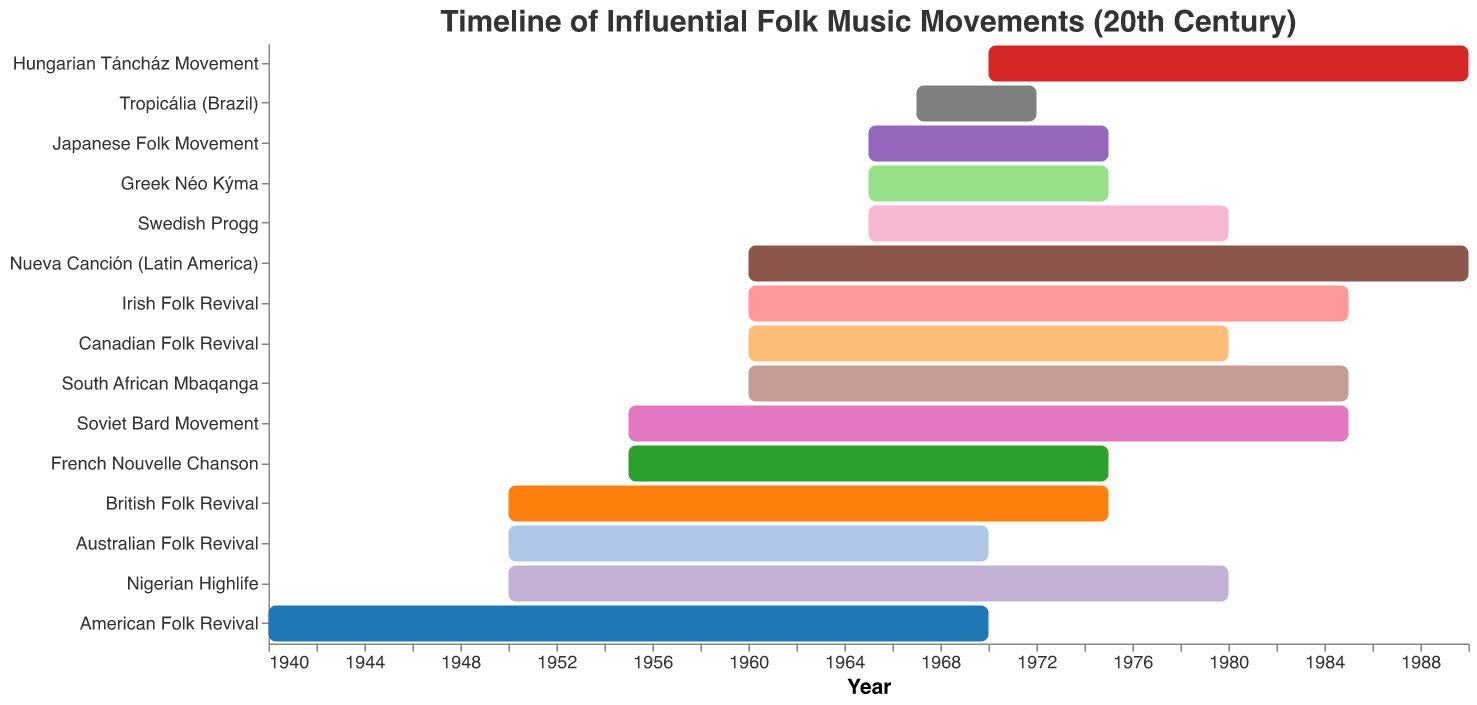What is the title of the chart? The title of the chart is usually located at the top and clearly states what the chart is about. By reading the title, we see that it's called "Timeline of Influential Folk Music Movements (20th Century)".
Answer: Timeline of Influential Folk Music Movements (20th Century) Which folk music movement has the longest duration? To find the movement with the longest duration, calculate the difference between the end and start years for each movement and compare them. Nueva Canción (Latin America) spans from 1960 to 1990, lasting 30 years.
Answer: Nueva Canción (Latin America) Which two movements both started in 1950? By examining the chart, we can see that the British Folk Revival and Australian Folk Revival both began in 1950.
Answer: British Folk Revival, Australian Folk Revival How many folk movements started in the 1960s? Count the number of bars that have their start year in the 1960s. Nueva Canción (Latin America), Irish Folk Revival, South African Mbaqanga, and Japanese Folk Movement started during this period, making a total of 4.
Answer: 4 Which movement ended last? By identifying the movement with the latest end year, we see that Nueva Canción (Latin America) ended in 1990, which is the latest among all the listed movements.
Answer: Nueva Canción (Latin America) What is the median start year of all the folk movements listed? List all start years: 1940, 1950, 1950, 1955, 1955, 1960, 1960, 1960, 1960, 1965, 1965, 1965, 1967, 1970. The median falls between 1960 and 1960, so the median start year is 1960.
Answer: 1960 Which movement had the shortest duration and how long did it last? Compare the duration of each movement by subtracting the start year from the end year. Tropicália (Brazil) lasted from 1967 to 1972, which is 5 years, the shortest among all movements.
Answer: Tropicália (Brazil), 5 years During which years were the most number of movements simultaneously active? To determine this, we need to count the overlapping years of the movements. In the year 1970, the majority of movements are active: American Folk Revival, British Folk Revival, Soviet Bard Movement, Australian Folk Revival, Nigerian Highlife, Irish Folk Revival, Japanese Folk Movement, French Nouvelle Chanson, South African Mbaqanga, Greek Néo Kýma, and Swedish Progg. This year features 11 overlapping movements.
Answer: 1970 How many movements have an end year before 1980? We count the movements on the chart that have an end year before 1980: American Folk Revival, British Folk Revival, Tropicália (Brazil), Australian Folk Revival, Japanese Folk Movement, French Nouvelle Chanson, Greek Néo Kýma. There are 7 movements in total.
Answer: 7 